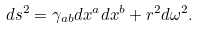Convert formula to latex. <formula><loc_0><loc_0><loc_500><loc_500>d s ^ { 2 } = \gamma _ { a b } d x ^ { a } d x ^ { b } + r ^ { 2 } d \omega ^ { 2 } .</formula> 